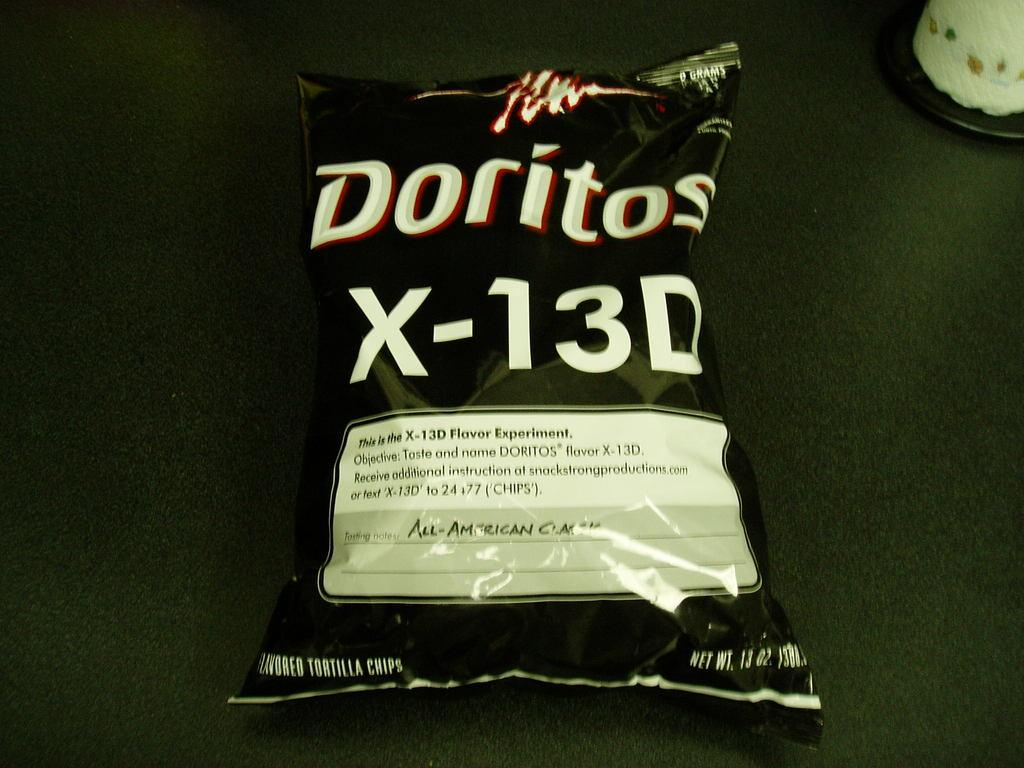<image>
Summarize the visual content of the image. A Doritos bag is labeled x-13D and is black in color. 